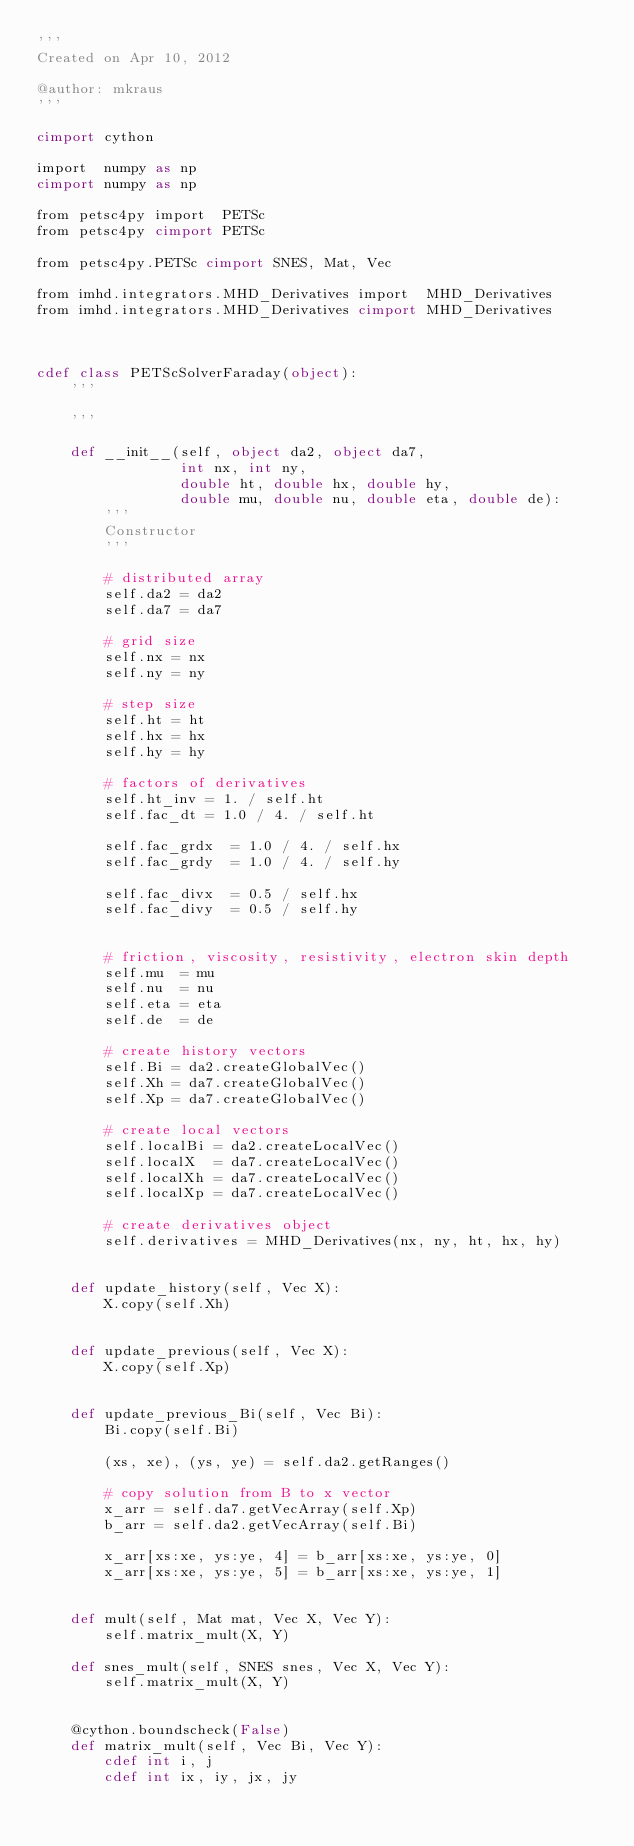<code> <loc_0><loc_0><loc_500><loc_500><_Cython_>'''
Created on Apr 10, 2012

@author: mkraus
'''

cimport cython

import  numpy as np
cimport numpy as np

from petsc4py import  PETSc
from petsc4py cimport PETSc

from petsc4py.PETSc cimport SNES, Mat, Vec

from imhd.integrators.MHD_Derivatives import  MHD_Derivatives
from imhd.integrators.MHD_Derivatives cimport MHD_Derivatives



cdef class PETScSolverFaraday(object):
    '''
    
    '''
    
    def __init__(self, object da2, object da7,
                 int nx, int ny,
                 double ht, double hx, double hy,
                 double mu, double nu, double eta, double de):
        '''
        Constructor
        '''
        
        # distributed array
        self.da2 = da2
        self.da7 = da7
        
        # grid size
        self.nx = nx
        self.ny = ny
        
        # step size
        self.ht = ht
        self.hx = hx
        self.hy = hy
        
        # factors of derivatives
        self.ht_inv = 1. / self.ht
        self.fac_dt = 1.0 / 4. / self.ht
        
        self.fac_grdx  = 1.0 / 4. / self.hx
        self.fac_grdy  = 1.0 / 4. / self.hy
        
        self.fac_divx  = 0.5 / self.hx
        self.fac_divy  = 0.5 / self.hy
        
        
        # friction, viscosity, resistivity, electron skin depth
        self.mu  = mu
        self.nu  = nu
        self.eta = eta
        self.de  = de
        
        # create history vectors
        self.Bi = da2.createGlobalVec()
        self.Xh = da7.createGlobalVec()
        self.Xp = da7.createGlobalVec()
        
        # create local vectors
        self.localBi = da2.createLocalVec()
        self.localX  = da7.createLocalVec()
        self.localXh = da7.createLocalVec()
        self.localXp = da7.createLocalVec()
        
        # create derivatives object
        self.derivatives = MHD_Derivatives(nx, ny, ht, hx, hy)
        
    
    def update_history(self, Vec X):
        X.copy(self.Xh)
        
    
    def update_previous(self, Vec X):
        X.copy(self.Xp)
        
    
    def update_previous_Bi(self, Vec Bi):
        Bi.copy(self.Bi)
        
        (xs, xe), (ys, ye) = self.da2.getRanges()
        
        # copy solution from B to x vector
        x_arr = self.da7.getVecArray(self.Xp)
        b_arr = self.da2.getVecArray(self.Bi)
        
        x_arr[xs:xe, ys:ye, 4] = b_arr[xs:xe, ys:ye, 0]
        x_arr[xs:xe, ys:ye, 5] = b_arr[xs:xe, ys:ye, 1]
        
    
    def mult(self, Mat mat, Vec X, Vec Y):
        self.matrix_mult(X, Y)
        
    def snes_mult(self, SNES snes, Vec X, Vec Y):
        self.matrix_mult(X, Y)
        
    
    @cython.boundscheck(False)
    def matrix_mult(self, Vec Bi, Vec Y):
        cdef int i, j
        cdef int ix, iy, jx, jy</code> 